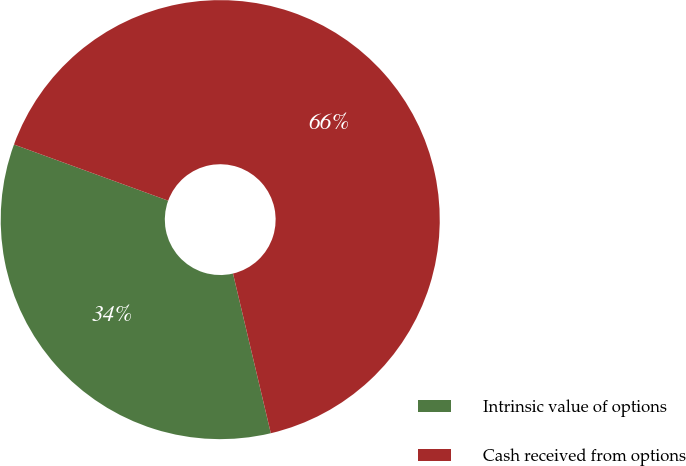Convert chart to OTSL. <chart><loc_0><loc_0><loc_500><loc_500><pie_chart><fcel>Intrinsic value of options<fcel>Cash received from options<nl><fcel>34.26%<fcel>65.74%<nl></chart> 